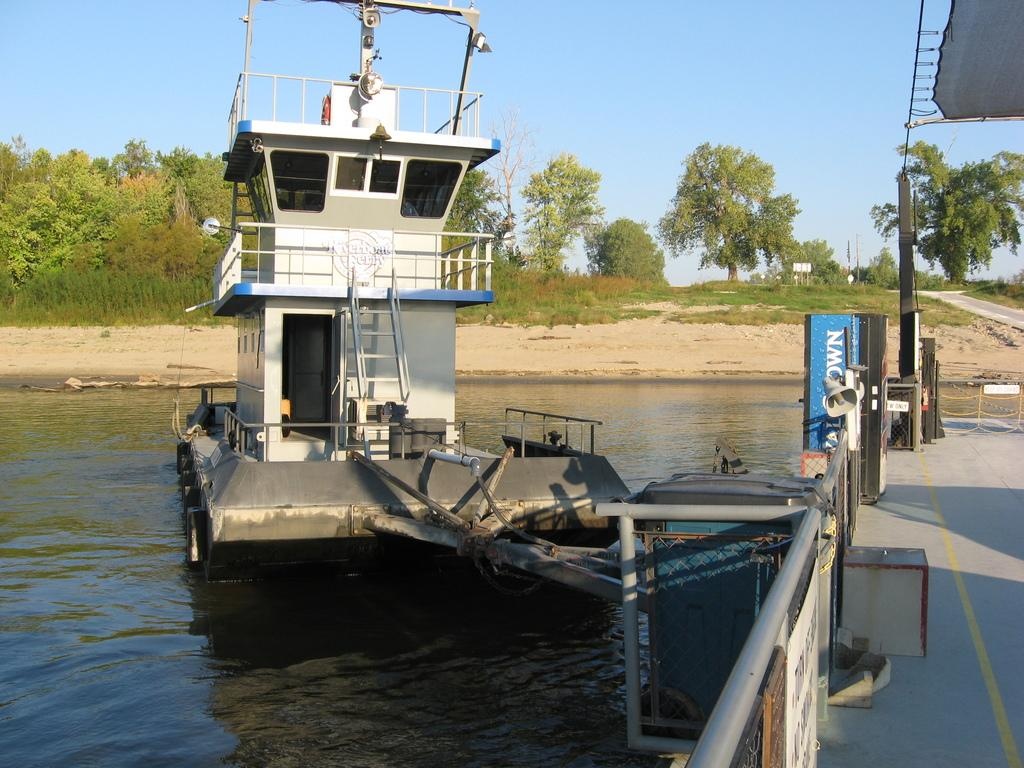What is the main subject of the image? The main subject of the image is boats. Where are the boats located? The boats are on the water. What can be seen in the background of the image? There are trees and the sky visible in the background of the image. How many chickens are sitting on the boats in the image? There are no chickens present in the image; it features boats on the water with trees and the sky in the background. Is there a squirrel wearing a sweater in the image? There is no squirrel, wearing a sweater or not, present in the image. 